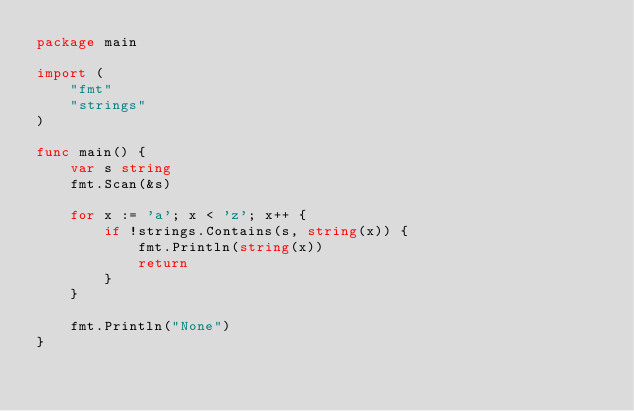Convert code to text. <code><loc_0><loc_0><loc_500><loc_500><_Go_>package main

import (
	"fmt"
	"strings"
)

func main() {
	var s string
	fmt.Scan(&s)

	for x := 'a'; x < 'z'; x++ {
		if !strings.Contains(s, string(x)) {
			fmt.Println(string(x))
			return
		}
	}

	fmt.Println("None")
}
</code> 